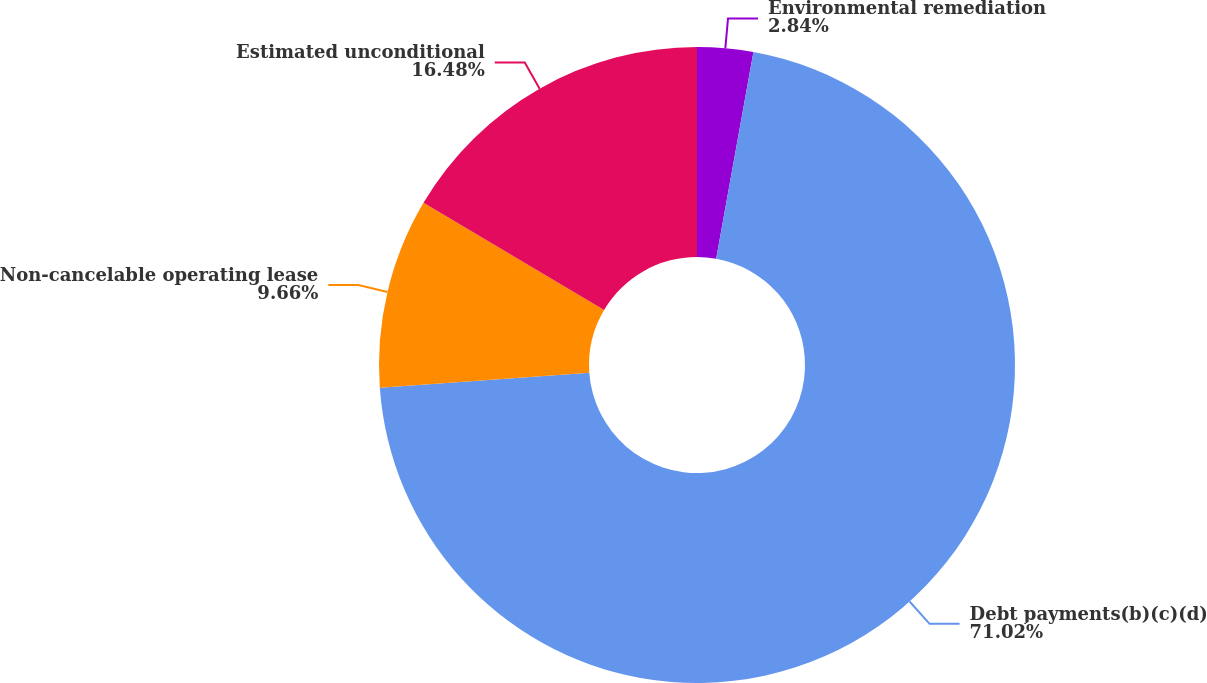Convert chart. <chart><loc_0><loc_0><loc_500><loc_500><pie_chart><fcel>Environmental remediation<fcel>Debt payments(b)(c)(d)<fcel>Non-cancelable operating lease<fcel>Estimated unconditional<nl><fcel>2.84%<fcel>71.02%<fcel>9.66%<fcel>16.48%<nl></chart> 